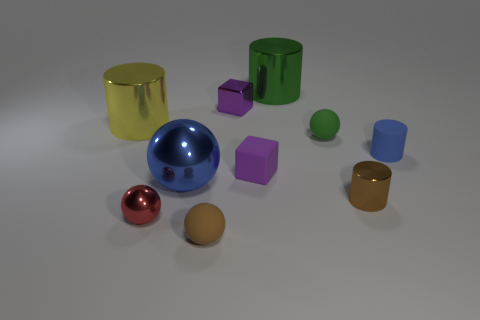Is the big metal ball the same color as the tiny matte cylinder?
Ensure brevity in your answer.  Yes. There is a cylinder that is behind the big yellow object; is it the same color as the small rubber sphere behind the purple rubber cube?
Keep it short and to the point. Yes. What is the size of the blue metal thing that is the same shape as the small red metallic object?
Provide a short and direct response. Large. Are there any brown objects behind the big green metallic object?
Ensure brevity in your answer.  No. Are there an equal number of large balls in front of the blue shiny ball and tiny blue metallic blocks?
Keep it short and to the point. Yes. Is there a green metallic cylinder that is in front of the big thing that is in front of the sphere that is on the right side of the purple rubber thing?
Give a very brief answer. No. What is the material of the small green ball?
Keep it short and to the point. Rubber. What number of other things are the same shape as the big blue thing?
Provide a succinct answer. 3. Does the blue matte thing have the same shape as the big green metallic thing?
Make the answer very short. Yes. What number of things are tiny matte things that are to the right of the green ball or cylinders that are to the right of the tiny purple rubber cube?
Your answer should be compact. 3. 